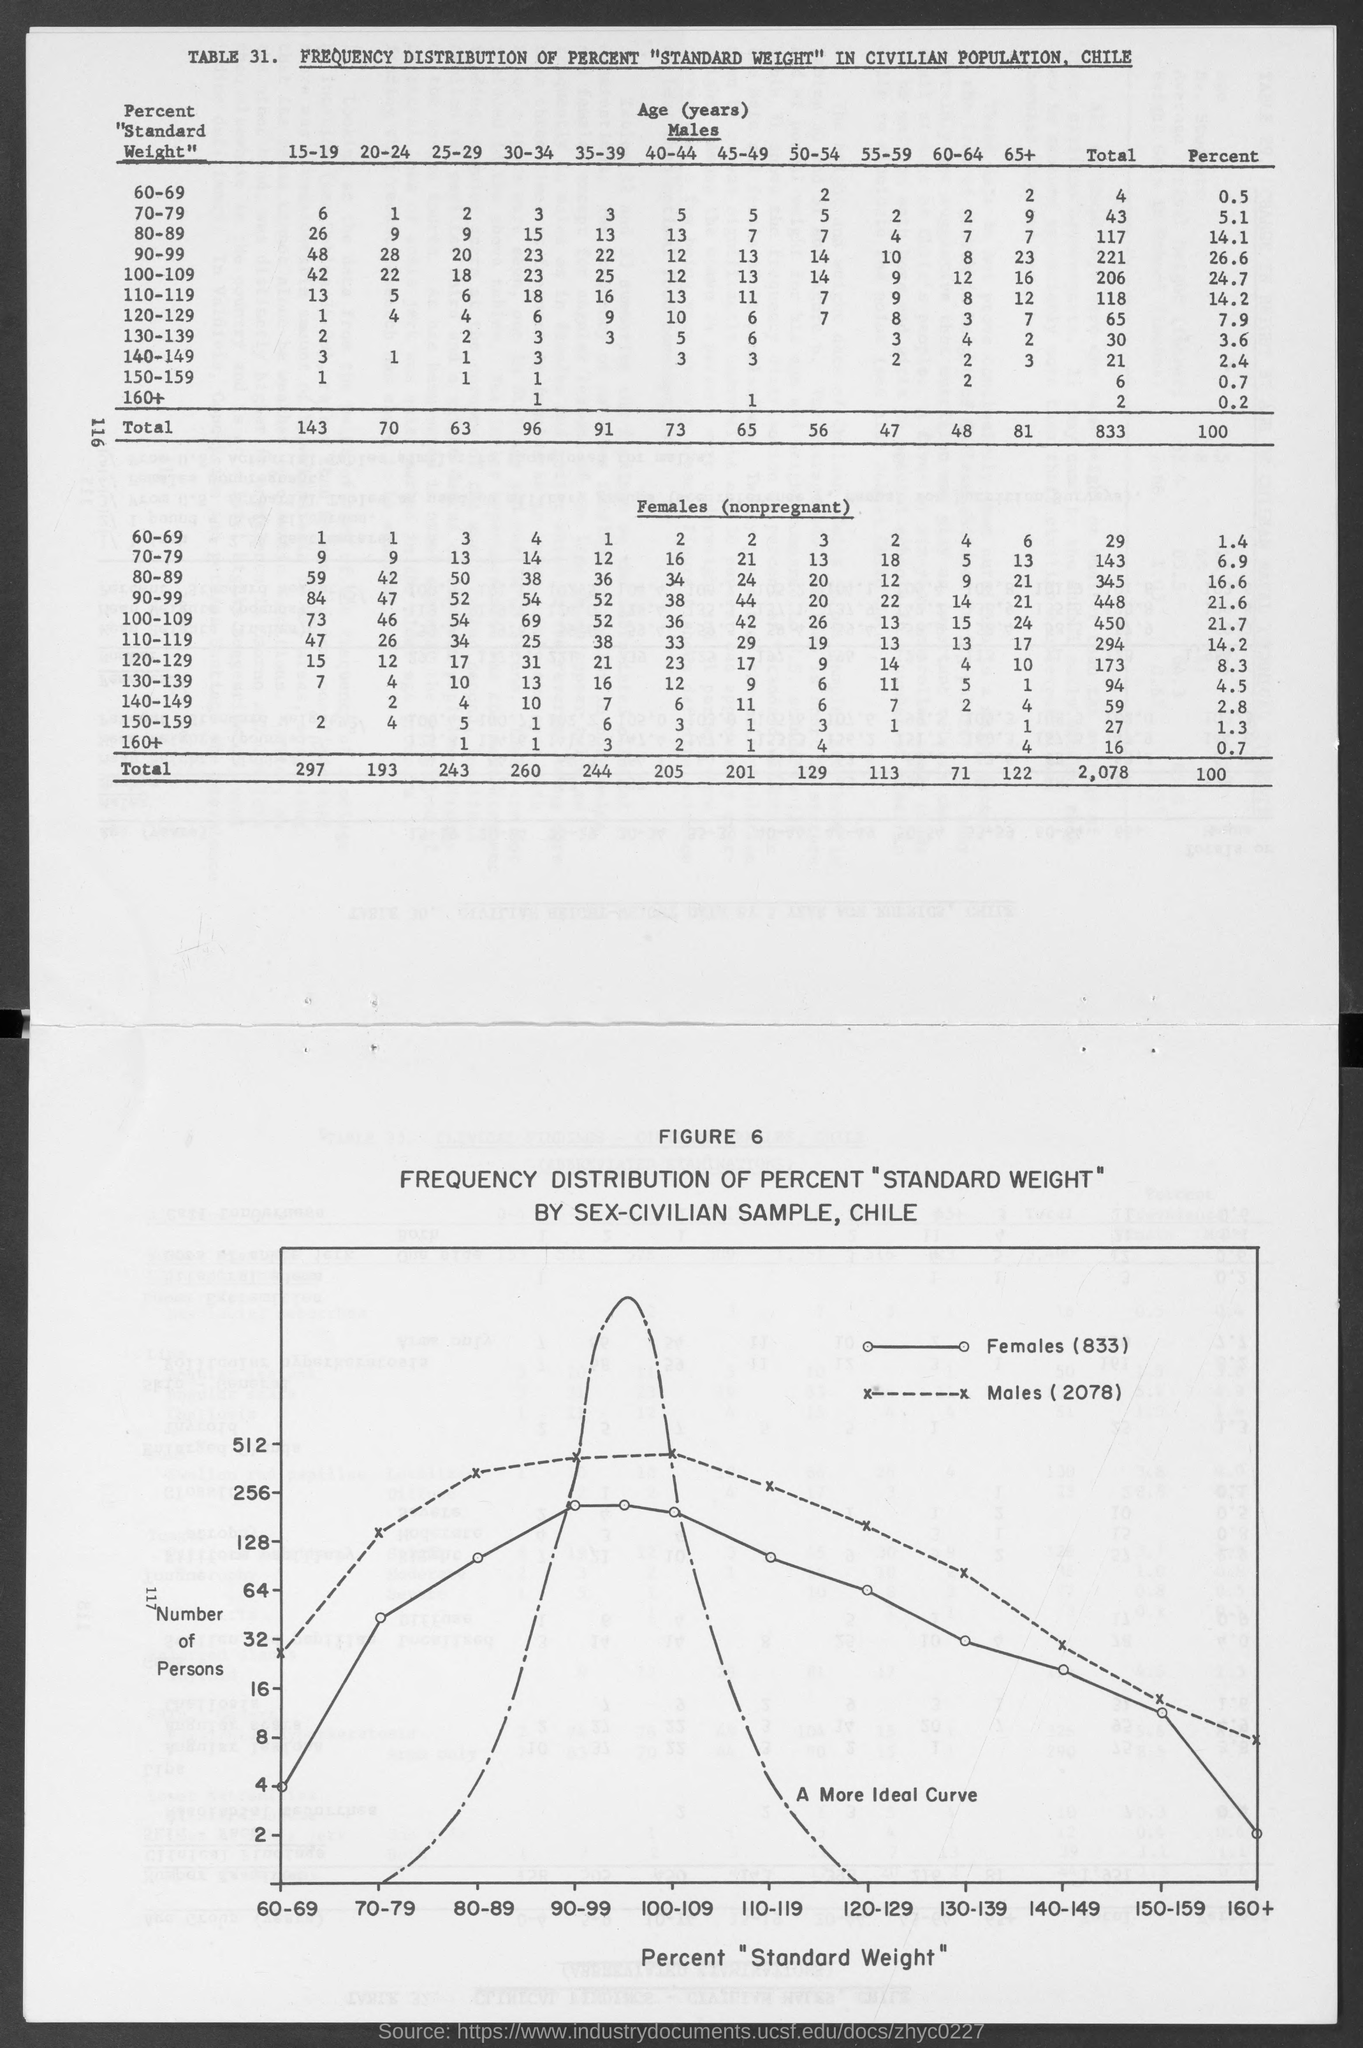Mention a couple of crucial points in this snapshot. There were a total of 2078 males mentioned in the graph. The table number is 31. There are a total of 29 females who weigh between 60 and 69 kilograms. Nearly 1.3% of females have a weight between 150-159. The number of figures is six. 